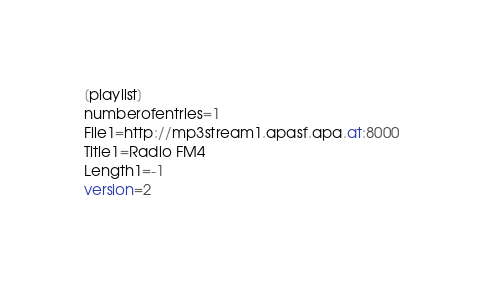<code> <loc_0><loc_0><loc_500><loc_500><_SQL_>[playlist]
numberofentries=1
File1=http://mp3stream1.apasf.apa.at:8000
Title1=Radio FM4
Length1=-1
version=2
</code> 